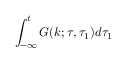Convert formula to latex. <formula><loc_0><loc_0><loc_500><loc_500>\int _ { - \infty } ^ { t } G ( k ; \tau , \tau _ { 1 } ) d \tau _ { 1 }</formula> 